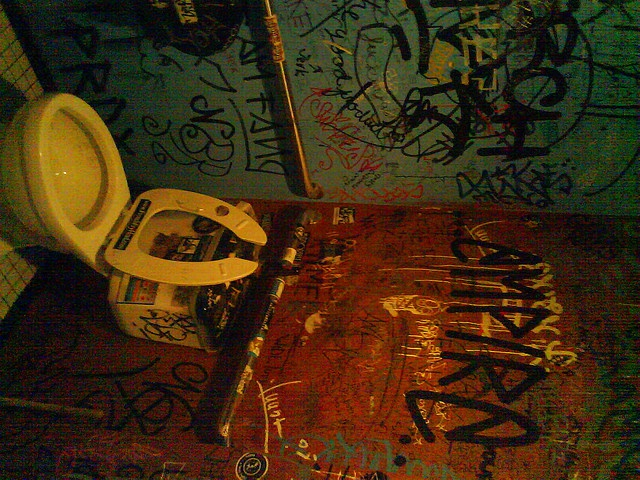Describe the objects in this image and their specific colors. I can see a toilet in black, olive, and maroon tones in this image. 